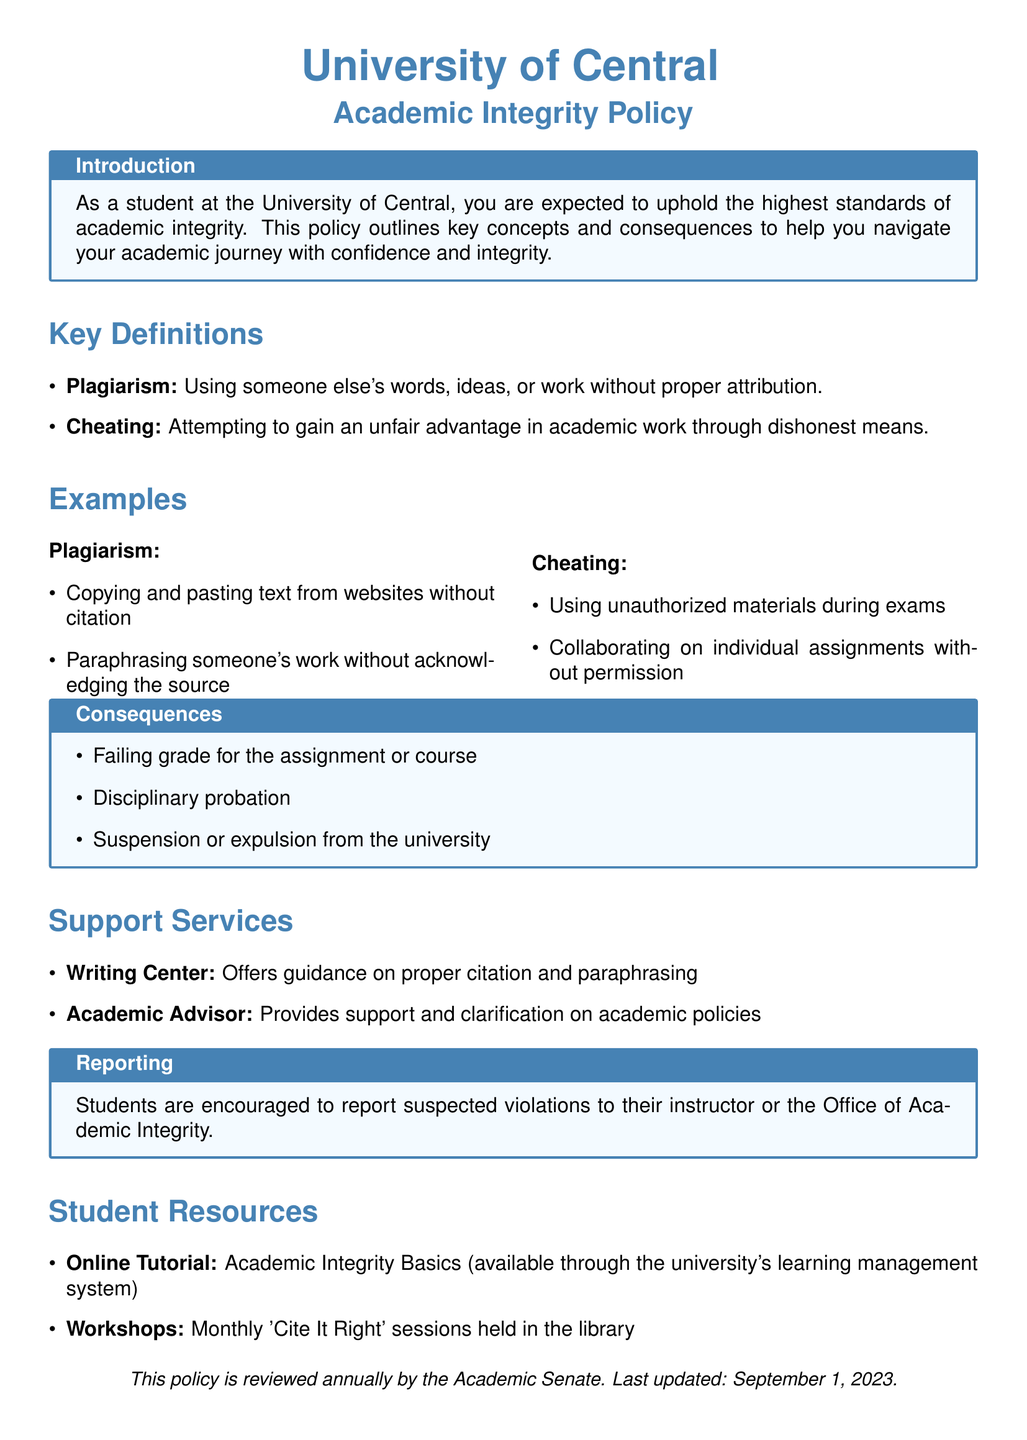what is the title of the document? The title appears at the top of the document indicating its main subject.
Answer: Academic Integrity Policy what does plagiarism mean? The definition of plagiarism is provided under key definitions in the document.
Answer: Using someone else's words, ideas, or work without proper attribution what is one example of cheating mentioned? The document lists specific examples of cheating in the examples section.
Answer: Using unauthorized materials during exams what are the consequences of a violation? The document outlines the consequences in a dedicated box, providing specific outcomes.
Answer: Failing grade for the assignment or course who can students report suspected violations to? The reporting section specifies whom students should approach for suspected violations.
Answer: Their instructor or the Office of Academic Integrity what support service helps with citations? The support services section lists various resources available for student assistance.
Answer: Writing Center how often are the 'Cite It Right' workshops held? The document specifies the frequency of these workshops in the student resources section.
Answer: Monthly when was the policy last updated? The document provides the last update date at the bottom.
Answer: September 1, 2023 